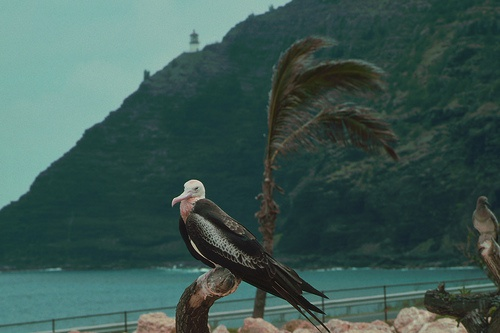Describe the objects in this image and their specific colors. I can see bird in turquoise, black, gray, and darkgray tones and bird in turquoise, gray, and black tones in this image. 